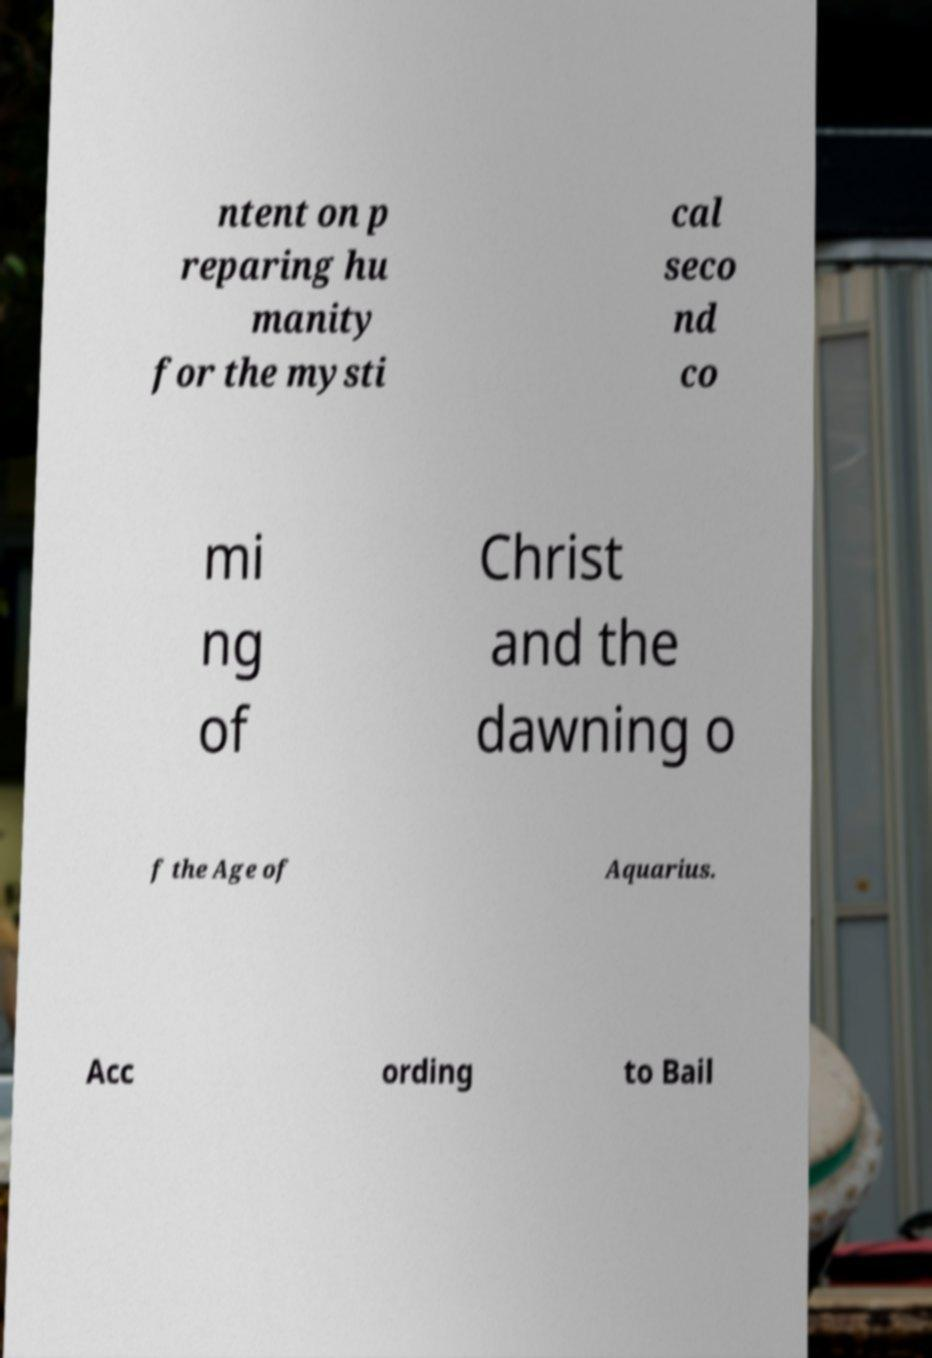Please read and relay the text visible in this image. What does it say? ntent on p reparing hu manity for the mysti cal seco nd co mi ng of Christ and the dawning o f the Age of Aquarius. Acc ording to Bail 